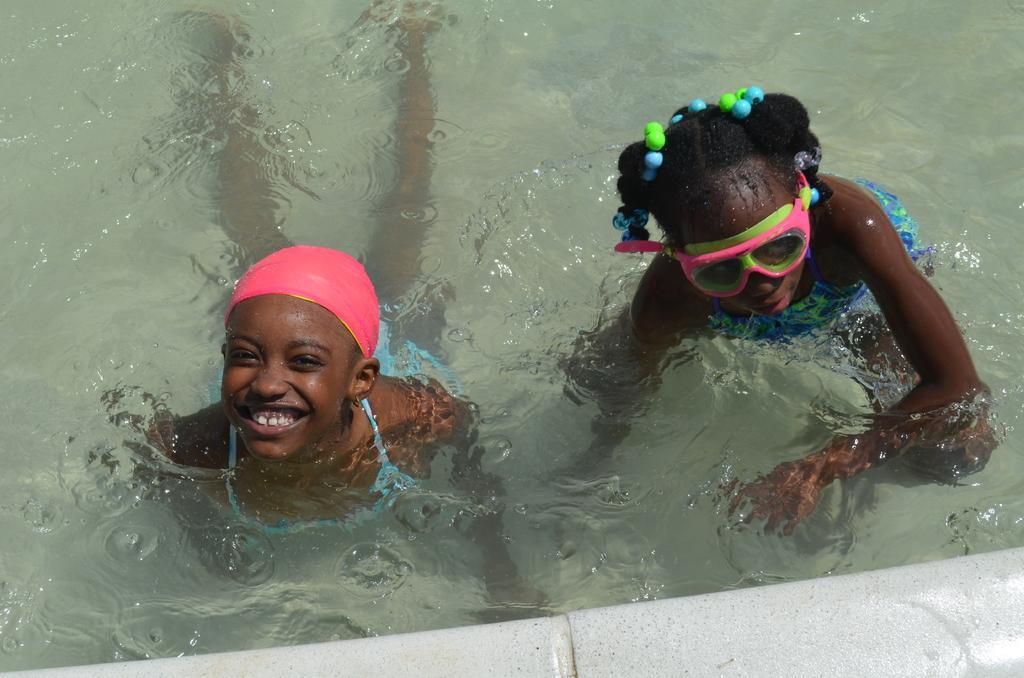In one or two sentences, can you explain what this image depicts? In this picture there are two girls in the center of the image in a swimming pool. 